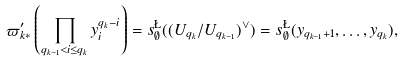Convert formula to latex. <formula><loc_0><loc_0><loc_500><loc_500>\varpi _ { k * } ^ { \prime } \left ( \prod _ { q _ { k - 1 } < i \leq q _ { k } } y _ { i } ^ { q _ { k } - i } \right ) = s ^ { \L } _ { \emptyset } ( ( U _ { q _ { k } } / U _ { q _ { k - 1 } } ) ^ { \vee } ) = s ^ { \L } _ { \emptyset } ( y _ { q _ { k - 1 } + 1 } , \dots , y _ { q _ { k } } ) ,</formula> 